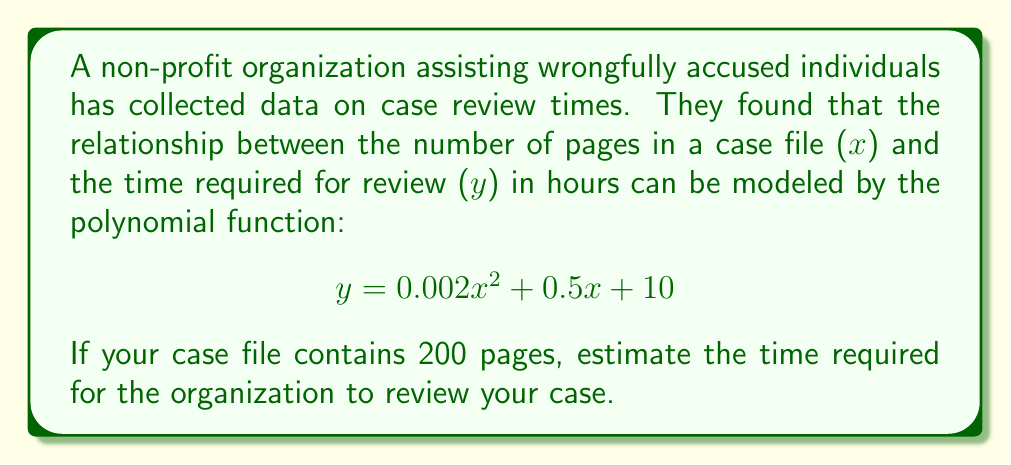Can you answer this question? To estimate the time required for case review, we need to substitute the given value of $x = 200$ into the polynomial function.

Step 1: Substitute $x = 200$ into the equation
$$y = 0.002(200)^2 + 0.5(200) + 10$$

Step 2: Calculate the squared term
$$(200)^2 = 40,000$$
$$y = 0.002(40,000) + 0.5(200) + 10$$

Step 3: Multiply the coefficients
$$y = 80 + 100 + 10$$

Step 4: Sum up all terms
$$y = 190$$

Therefore, the estimated time required for the organization to review a 200-page case file is 190 hours.
Answer: 190 hours 